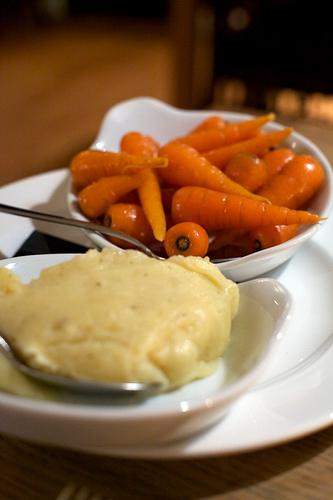Question: how many bowls are on the bigger plate?
Choices:
A. One.
B. Two.
C. Three.
D. Four.
Answer with the letter. Answer: B Question: what is the orange vegetable?
Choices:
A. Oranges.
B. Peppers.
C. Carrots.
D. No vegetable.
Answer with the letter. Answer: C Question: what utensil is beside the foods?
Choices:
A. Forks.
B. Spoons.
C. Knives.
D. Spatulas.
Answer with the letter. Answer: B Question: how does the food look?
Choices:
A. Burnt.
B. Undercooked.
C. Delicious.
D. Hot.
Answer with the letter. Answer: C 